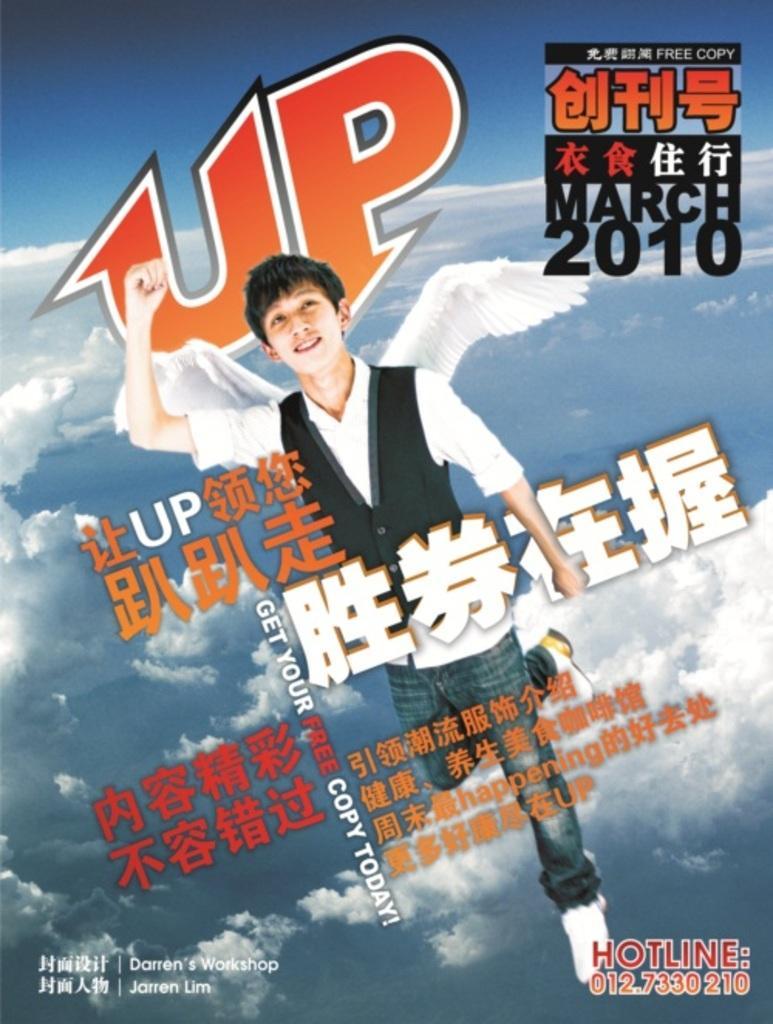Please provide a concise description of this image. This might be a poster in this image in the center there is one person and wings and in the foreground there is text, in the background there are some clouds. 